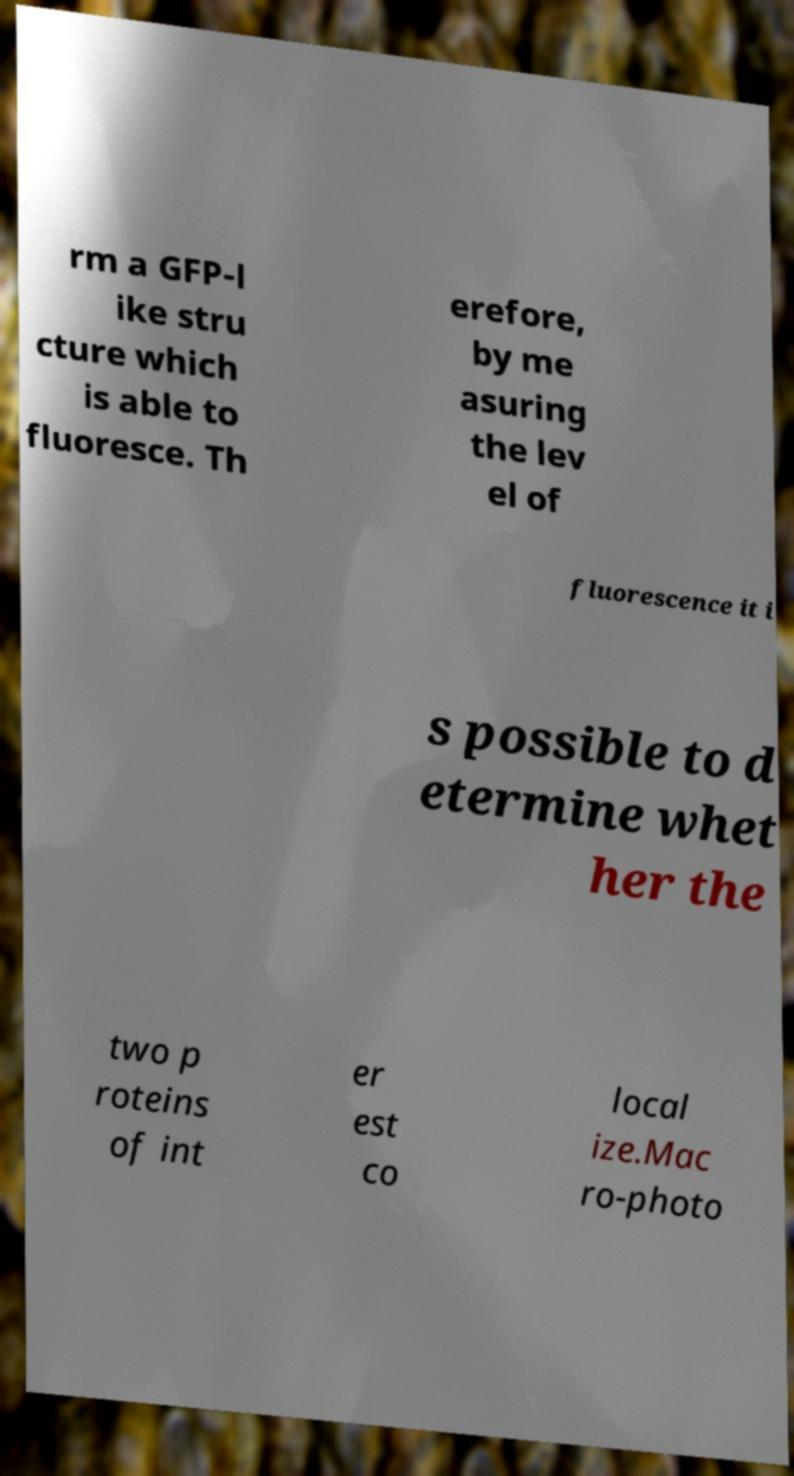Could you assist in decoding the text presented in this image and type it out clearly? rm a GFP-l ike stru cture which is able to fluoresce. Th erefore, by me asuring the lev el of fluorescence it i s possible to d etermine whet her the two p roteins of int er est co local ize.Mac ro-photo 